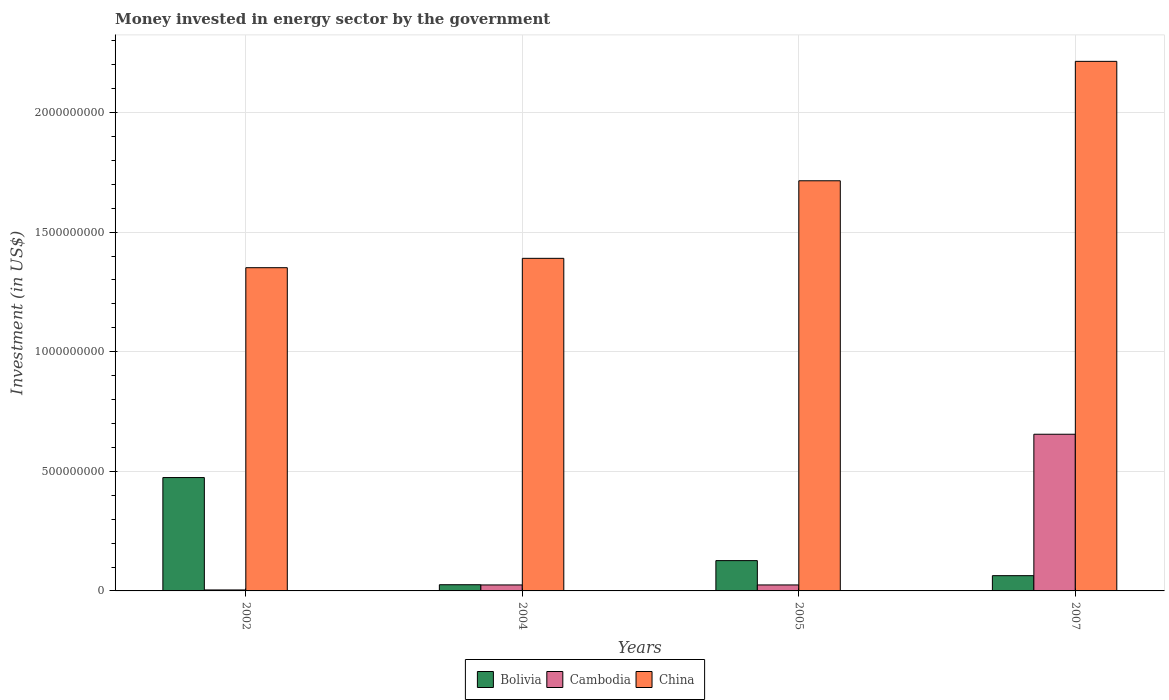How many different coloured bars are there?
Provide a short and direct response. 3. How many groups of bars are there?
Provide a short and direct response. 4. How many bars are there on the 2nd tick from the left?
Your answer should be compact. 3. How many bars are there on the 4th tick from the right?
Offer a very short reply. 3. What is the label of the 3rd group of bars from the left?
Your response must be concise. 2005. In how many cases, is the number of bars for a given year not equal to the number of legend labels?
Your answer should be compact. 0. What is the money spent in energy sector in Cambodia in 2005?
Provide a short and direct response. 2.50e+07. Across all years, what is the maximum money spent in energy sector in China?
Offer a very short reply. 2.21e+09. Across all years, what is the minimum money spent in energy sector in Bolivia?
Provide a succinct answer. 2.59e+07. In which year was the money spent in energy sector in Cambodia minimum?
Your answer should be compact. 2002. What is the total money spent in energy sector in China in the graph?
Your answer should be compact. 6.67e+09. What is the difference between the money spent in energy sector in China in 2004 and that in 2007?
Offer a very short reply. -8.24e+08. What is the difference between the money spent in energy sector in Bolivia in 2005 and the money spent in energy sector in Cambodia in 2004?
Offer a terse response. 1.02e+08. What is the average money spent in energy sector in Bolivia per year?
Keep it short and to the point. 1.73e+08. In the year 2002, what is the difference between the money spent in energy sector in Cambodia and money spent in energy sector in Bolivia?
Ensure brevity in your answer.  -4.70e+08. In how many years, is the money spent in energy sector in Cambodia greater than 300000000 US$?
Give a very brief answer. 1. What is the ratio of the money spent in energy sector in Bolivia in 2002 to that in 2005?
Your answer should be compact. 3.74. Is the difference between the money spent in energy sector in Cambodia in 2004 and 2005 greater than the difference between the money spent in energy sector in Bolivia in 2004 and 2005?
Your answer should be very brief. Yes. What is the difference between the highest and the second highest money spent in energy sector in China?
Offer a very short reply. 4.99e+08. What is the difference between the highest and the lowest money spent in energy sector in Cambodia?
Keep it short and to the point. 6.51e+08. In how many years, is the money spent in energy sector in China greater than the average money spent in energy sector in China taken over all years?
Provide a succinct answer. 2. Is the sum of the money spent in energy sector in Cambodia in 2004 and 2007 greater than the maximum money spent in energy sector in China across all years?
Give a very brief answer. No. Is it the case that in every year, the sum of the money spent in energy sector in China and money spent in energy sector in Bolivia is greater than the money spent in energy sector in Cambodia?
Provide a short and direct response. Yes. Are all the bars in the graph horizontal?
Provide a short and direct response. No. Does the graph contain any zero values?
Your response must be concise. No. Does the graph contain grids?
Provide a succinct answer. Yes. How many legend labels are there?
Your answer should be very brief. 3. What is the title of the graph?
Make the answer very short. Money invested in energy sector by the government. Does "Libya" appear as one of the legend labels in the graph?
Your answer should be very brief. No. What is the label or title of the Y-axis?
Keep it short and to the point. Investment (in US$). What is the Investment (in US$) of Bolivia in 2002?
Provide a short and direct response. 4.74e+08. What is the Investment (in US$) of Cambodia in 2002?
Give a very brief answer. 4.10e+06. What is the Investment (in US$) in China in 2002?
Your response must be concise. 1.35e+09. What is the Investment (in US$) of Bolivia in 2004?
Your answer should be compact. 2.59e+07. What is the Investment (in US$) in Cambodia in 2004?
Your answer should be compact. 2.50e+07. What is the Investment (in US$) in China in 2004?
Your answer should be very brief. 1.39e+09. What is the Investment (in US$) of Bolivia in 2005?
Provide a short and direct response. 1.27e+08. What is the Investment (in US$) of Cambodia in 2005?
Your answer should be very brief. 2.50e+07. What is the Investment (in US$) of China in 2005?
Provide a succinct answer. 1.71e+09. What is the Investment (in US$) in Bolivia in 2007?
Ensure brevity in your answer.  6.38e+07. What is the Investment (in US$) of Cambodia in 2007?
Make the answer very short. 6.55e+08. What is the Investment (in US$) of China in 2007?
Provide a succinct answer. 2.21e+09. Across all years, what is the maximum Investment (in US$) of Bolivia?
Provide a succinct answer. 4.74e+08. Across all years, what is the maximum Investment (in US$) in Cambodia?
Your response must be concise. 6.55e+08. Across all years, what is the maximum Investment (in US$) in China?
Keep it short and to the point. 2.21e+09. Across all years, what is the minimum Investment (in US$) of Bolivia?
Provide a succinct answer. 2.59e+07. Across all years, what is the minimum Investment (in US$) of Cambodia?
Provide a succinct answer. 4.10e+06. Across all years, what is the minimum Investment (in US$) in China?
Give a very brief answer. 1.35e+09. What is the total Investment (in US$) in Bolivia in the graph?
Keep it short and to the point. 6.90e+08. What is the total Investment (in US$) in Cambodia in the graph?
Offer a terse response. 7.09e+08. What is the total Investment (in US$) in China in the graph?
Offer a terse response. 6.67e+09. What is the difference between the Investment (in US$) of Bolivia in 2002 and that in 2004?
Ensure brevity in your answer.  4.48e+08. What is the difference between the Investment (in US$) of Cambodia in 2002 and that in 2004?
Provide a succinct answer. -2.09e+07. What is the difference between the Investment (in US$) of China in 2002 and that in 2004?
Provide a short and direct response. -3.92e+07. What is the difference between the Investment (in US$) of Bolivia in 2002 and that in 2005?
Ensure brevity in your answer.  3.47e+08. What is the difference between the Investment (in US$) in Cambodia in 2002 and that in 2005?
Offer a very short reply. -2.09e+07. What is the difference between the Investment (in US$) of China in 2002 and that in 2005?
Offer a terse response. -3.63e+08. What is the difference between the Investment (in US$) of Bolivia in 2002 and that in 2007?
Make the answer very short. 4.10e+08. What is the difference between the Investment (in US$) in Cambodia in 2002 and that in 2007?
Give a very brief answer. -6.51e+08. What is the difference between the Investment (in US$) in China in 2002 and that in 2007?
Keep it short and to the point. -8.63e+08. What is the difference between the Investment (in US$) of Bolivia in 2004 and that in 2005?
Your response must be concise. -1.01e+08. What is the difference between the Investment (in US$) in China in 2004 and that in 2005?
Make the answer very short. -3.24e+08. What is the difference between the Investment (in US$) of Bolivia in 2004 and that in 2007?
Your response must be concise. -3.79e+07. What is the difference between the Investment (in US$) of Cambodia in 2004 and that in 2007?
Provide a short and direct response. -6.30e+08. What is the difference between the Investment (in US$) of China in 2004 and that in 2007?
Your answer should be very brief. -8.24e+08. What is the difference between the Investment (in US$) in Bolivia in 2005 and that in 2007?
Your answer should be compact. 6.29e+07. What is the difference between the Investment (in US$) of Cambodia in 2005 and that in 2007?
Provide a short and direct response. -6.30e+08. What is the difference between the Investment (in US$) of China in 2005 and that in 2007?
Offer a terse response. -4.99e+08. What is the difference between the Investment (in US$) of Bolivia in 2002 and the Investment (in US$) of Cambodia in 2004?
Provide a short and direct response. 4.49e+08. What is the difference between the Investment (in US$) of Bolivia in 2002 and the Investment (in US$) of China in 2004?
Offer a very short reply. -9.16e+08. What is the difference between the Investment (in US$) in Cambodia in 2002 and the Investment (in US$) in China in 2004?
Make the answer very short. -1.39e+09. What is the difference between the Investment (in US$) of Bolivia in 2002 and the Investment (in US$) of Cambodia in 2005?
Offer a very short reply. 4.49e+08. What is the difference between the Investment (in US$) of Bolivia in 2002 and the Investment (in US$) of China in 2005?
Provide a succinct answer. -1.24e+09. What is the difference between the Investment (in US$) in Cambodia in 2002 and the Investment (in US$) in China in 2005?
Keep it short and to the point. -1.71e+09. What is the difference between the Investment (in US$) of Bolivia in 2002 and the Investment (in US$) of Cambodia in 2007?
Your answer should be compact. -1.81e+08. What is the difference between the Investment (in US$) of Bolivia in 2002 and the Investment (in US$) of China in 2007?
Provide a succinct answer. -1.74e+09. What is the difference between the Investment (in US$) in Cambodia in 2002 and the Investment (in US$) in China in 2007?
Provide a succinct answer. -2.21e+09. What is the difference between the Investment (in US$) of Bolivia in 2004 and the Investment (in US$) of China in 2005?
Your response must be concise. -1.69e+09. What is the difference between the Investment (in US$) in Cambodia in 2004 and the Investment (in US$) in China in 2005?
Make the answer very short. -1.69e+09. What is the difference between the Investment (in US$) in Bolivia in 2004 and the Investment (in US$) in Cambodia in 2007?
Your answer should be very brief. -6.29e+08. What is the difference between the Investment (in US$) in Bolivia in 2004 and the Investment (in US$) in China in 2007?
Provide a short and direct response. -2.19e+09. What is the difference between the Investment (in US$) of Cambodia in 2004 and the Investment (in US$) of China in 2007?
Keep it short and to the point. -2.19e+09. What is the difference between the Investment (in US$) in Bolivia in 2005 and the Investment (in US$) in Cambodia in 2007?
Your answer should be compact. -5.28e+08. What is the difference between the Investment (in US$) in Bolivia in 2005 and the Investment (in US$) in China in 2007?
Give a very brief answer. -2.09e+09. What is the difference between the Investment (in US$) of Cambodia in 2005 and the Investment (in US$) of China in 2007?
Make the answer very short. -2.19e+09. What is the average Investment (in US$) in Bolivia per year?
Provide a succinct answer. 1.73e+08. What is the average Investment (in US$) in Cambodia per year?
Offer a terse response. 1.77e+08. What is the average Investment (in US$) in China per year?
Provide a short and direct response. 1.67e+09. In the year 2002, what is the difference between the Investment (in US$) in Bolivia and Investment (in US$) in Cambodia?
Provide a short and direct response. 4.70e+08. In the year 2002, what is the difference between the Investment (in US$) in Bolivia and Investment (in US$) in China?
Provide a short and direct response. -8.77e+08. In the year 2002, what is the difference between the Investment (in US$) of Cambodia and Investment (in US$) of China?
Make the answer very short. -1.35e+09. In the year 2004, what is the difference between the Investment (in US$) in Bolivia and Investment (in US$) in Cambodia?
Offer a terse response. 9.00e+05. In the year 2004, what is the difference between the Investment (in US$) of Bolivia and Investment (in US$) of China?
Provide a succinct answer. -1.36e+09. In the year 2004, what is the difference between the Investment (in US$) of Cambodia and Investment (in US$) of China?
Offer a very short reply. -1.37e+09. In the year 2005, what is the difference between the Investment (in US$) of Bolivia and Investment (in US$) of Cambodia?
Provide a short and direct response. 1.02e+08. In the year 2005, what is the difference between the Investment (in US$) in Bolivia and Investment (in US$) in China?
Your response must be concise. -1.59e+09. In the year 2005, what is the difference between the Investment (in US$) of Cambodia and Investment (in US$) of China?
Provide a succinct answer. -1.69e+09. In the year 2007, what is the difference between the Investment (in US$) in Bolivia and Investment (in US$) in Cambodia?
Offer a terse response. -5.91e+08. In the year 2007, what is the difference between the Investment (in US$) of Bolivia and Investment (in US$) of China?
Make the answer very short. -2.15e+09. In the year 2007, what is the difference between the Investment (in US$) in Cambodia and Investment (in US$) in China?
Provide a short and direct response. -1.56e+09. What is the ratio of the Investment (in US$) in Bolivia in 2002 to that in 2004?
Keep it short and to the point. 18.3. What is the ratio of the Investment (in US$) in Cambodia in 2002 to that in 2004?
Ensure brevity in your answer.  0.16. What is the ratio of the Investment (in US$) in China in 2002 to that in 2004?
Keep it short and to the point. 0.97. What is the ratio of the Investment (in US$) of Bolivia in 2002 to that in 2005?
Provide a short and direct response. 3.74. What is the ratio of the Investment (in US$) in Cambodia in 2002 to that in 2005?
Your answer should be compact. 0.16. What is the ratio of the Investment (in US$) in China in 2002 to that in 2005?
Offer a terse response. 0.79. What is the ratio of the Investment (in US$) in Bolivia in 2002 to that in 2007?
Provide a short and direct response. 7.43. What is the ratio of the Investment (in US$) in Cambodia in 2002 to that in 2007?
Make the answer very short. 0.01. What is the ratio of the Investment (in US$) of China in 2002 to that in 2007?
Give a very brief answer. 0.61. What is the ratio of the Investment (in US$) of Bolivia in 2004 to that in 2005?
Your answer should be compact. 0.2. What is the ratio of the Investment (in US$) in China in 2004 to that in 2005?
Your response must be concise. 0.81. What is the ratio of the Investment (in US$) in Bolivia in 2004 to that in 2007?
Your answer should be compact. 0.41. What is the ratio of the Investment (in US$) in Cambodia in 2004 to that in 2007?
Ensure brevity in your answer.  0.04. What is the ratio of the Investment (in US$) of China in 2004 to that in 2007?
Offer a terse response. 0.63. What is the ratio of the Investment (in US$) in Bolivia in 2005 to that in 2007?
Offer a very short reply. 1.99. What is the ratio of the Investment (in US$) in Cambodia in 2005 to that in 2007?
Make the answer very short. 0.04. What is the ratio of the Investment (in US$) of China in 2005 to that in 2007?
Keep it short and to the point. 0.77. What is the difference between the highest and the second highest Investment (in US$) in Bolivia?
Give a very brief answer. 3.47e+08. What is the difference between the highest and the second highest Investment (in US$) in Cambodia?
Your answer should be very brief. 6.30e+08. What is the difference between the highest and the second highest Investment (in US$) in China?
Your response must be concise. 4.99e+08. What is the difference between the highest and the lowest Investment (in US$) in Bolivia?
Give a very brief answer. 4.48e+08. What is the difference between the highest and the lowest Investment (in US$) in Cambodia?
Make the answer very short. 6.51e+08. What is the difference between the highest and the lowest Investment (in US$) in China?
Ensure brevity in your answer.  8.63e+08. 